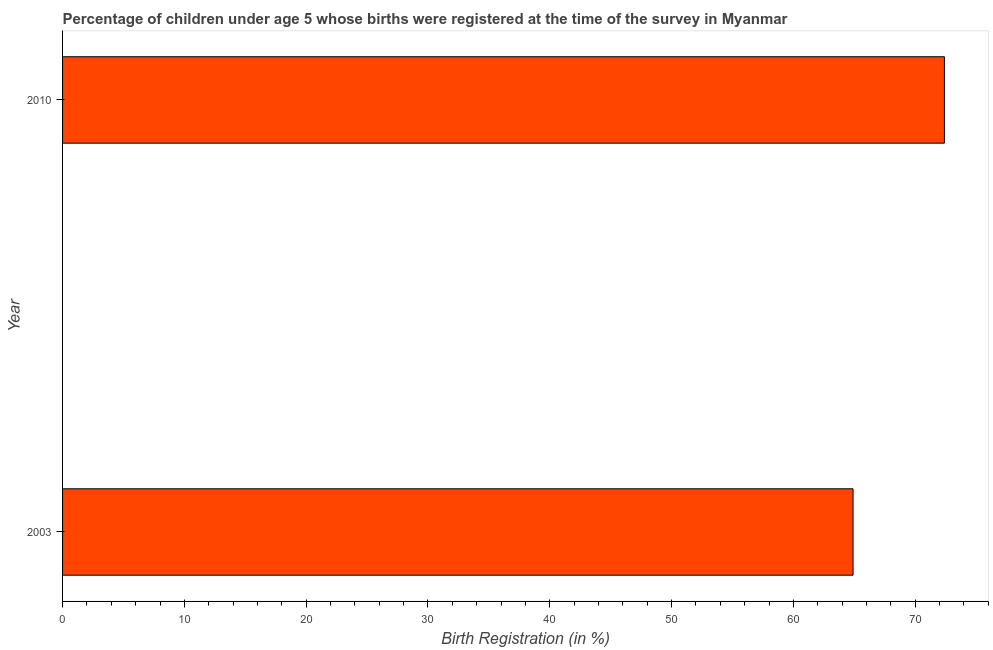Does the graph contain grids?
Your answer should be very brief. No. What is the title of the graph?
Your answer should be very brief. Percentage of children under age 5 whose births were registered at the time of the survey in Myanmar. What is the label or title of the X-axis?
Provide a succinct answer. Birth Registration (in %). What is the birth registration in 2010?
Your answer should be compact. 72.4. Across all years, what is the maximum birth registration?
Ensure brevity in your answer.  72.4. Across all years, what is the minimum birth registration?
Your answer should be compact. 64.9. What is the sum of the birth registration?
Provide a succinct answer. 137.3. What is the average birth registration per year?
Provide a short and direct response. 68.65. What is the median birth registration?
Provide a short and direct response. 68.65. In how many years, is the birth registration greater than 24 %?
Offer a terse response. 2. Do a majority of the years between 2003 and 2010 (inclusive) have birth registration greater than 68 %?
Your response must be concise. No. What is the ratio of the birth registration in 2003 to that in 2010?
Offer a very short reply. 0.9. In how many years, is the birth registration greater than the average birth registration taken over all years?
Ensure brevity in your answer.  1. How many bars are there?
Provide a succinct answer. 2. How many years are there in the graph?
Provide a succinct answer. 2. Are the values on the major ticks of X-axis written in scientific E-notation?
Make the answer very short. No. What is the Birth Registration (in %) of 2003?
Your response must be concise. 64.9. What is the Birth Registration (in %) in 2010?
Your answer should be compact. 72.4. What is the ratio of the Birth Registration (in %) in 2003 to that in 2010?
Offer a very short reply. 0.9. 